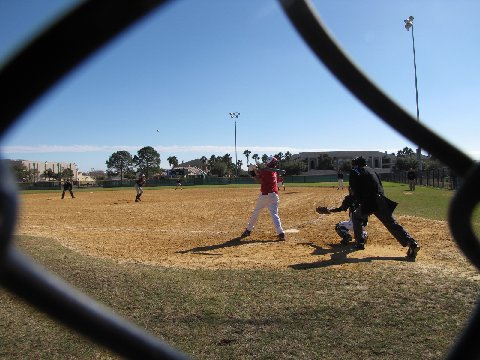What is the perspective from which the baseball game is being viewed? The viewer peers at the game through the diamond-shaped apertures of a chain link fence, which serves as both a physical barrier and a symbolic window into the earnest world of youth baseball, where every pitch and swing is charged with youthful enthusiasm. 